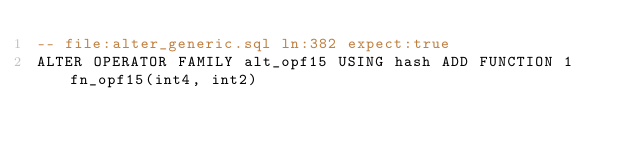Convert code to text. <code><loc_0><loc_0><loc_500><loc_500><_SQL_>-- file:alter_generic.sql ln:382 expect:true
ALTER OPERATOR FAMILY alt_opf15 USING hash ADD FUNCTION 1 fn_opf15(int4, int2)
</code> 